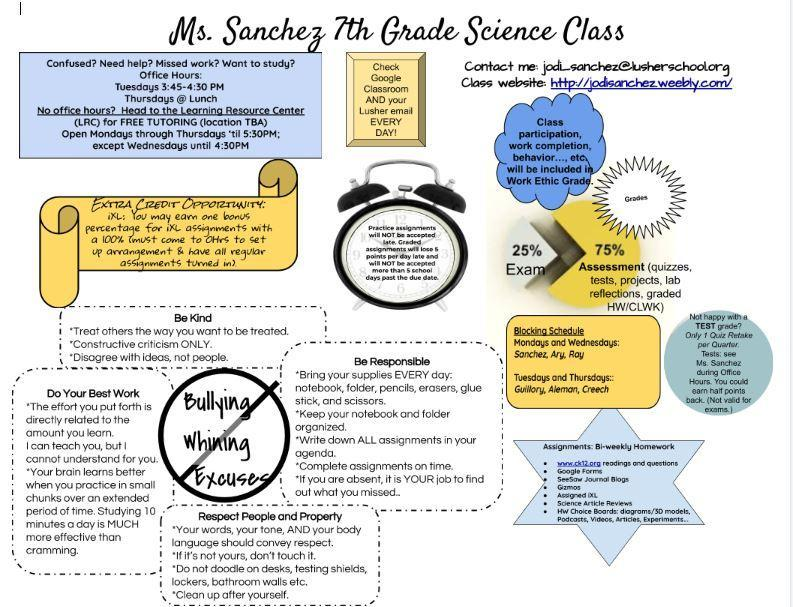What should not be done during the science class?
Answer the question with a short phrase. Bullying, Whining, Excuses 